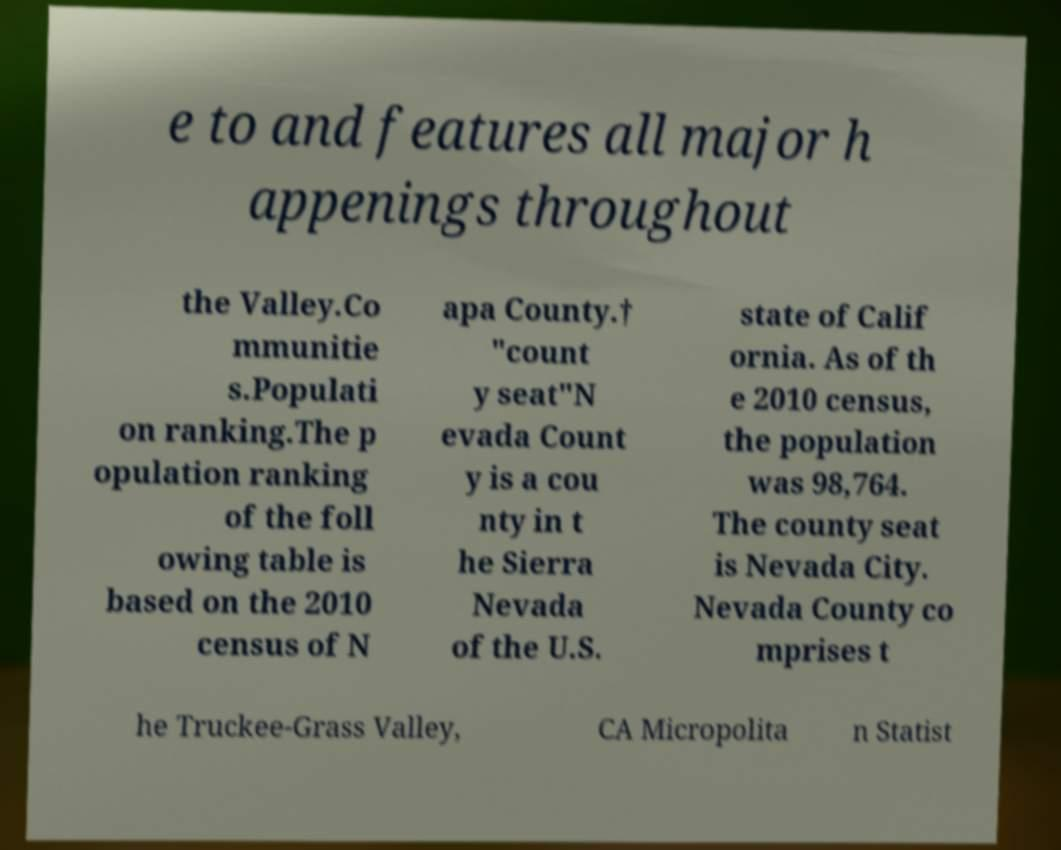Please identify and transcribe the text found in this image. e to and features all major h appenings throughout the Valley.Co mmunitie s.Populati on ranking.The p opulation ranking of the foll owing table is based on the 2010 census of N apa County.† "count y seat"N evada Count y is a cou nty in t he Sierra Nevada of the U.S. state of Calif ornia. As of th e 2010 census, the population was 98,764. The county seat is Nevada City. Nevada County co mprises t he Truckee-Grass Valley, CA Micropolita n Statist 